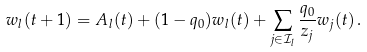Convert formula to latex. <formula><loc_0><loc_0><loc_500><loc_500>w _ { l } ( t + 1 ) = A _ { l } ( t ) + ( 1 - q _ { 0 } ) w _ { l } ( t ) + \sum _ { j \in \mathcal { I } _ { l } } \frac { q _ { 0 } } { z _ { j } } w _ { j } ( t ) \, .</formula> 